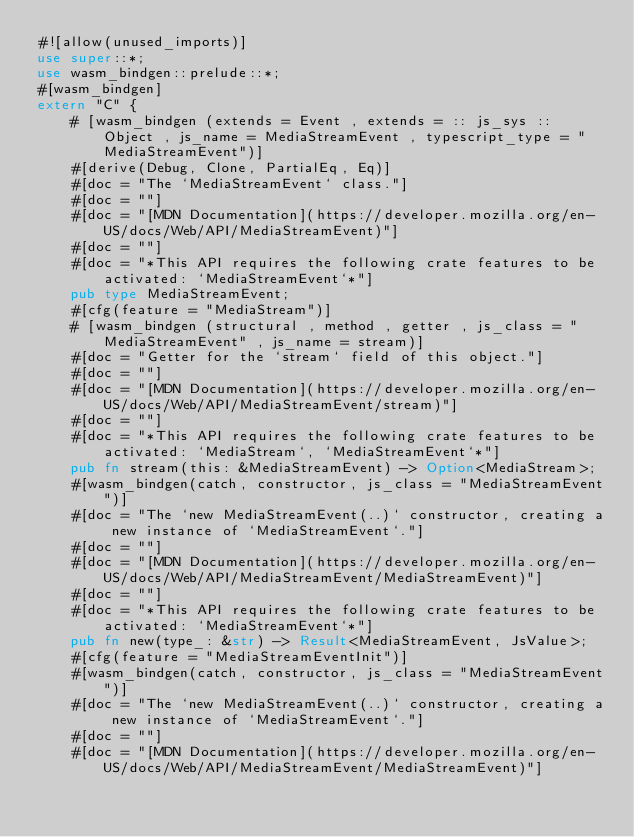<code> <loc_0><loc_0><loc_500><loc_500><_Rust_>#![allow(unused_imports)]
use super::*;
use wasm_bindgen::prelude::*;
#[wasm_bindgen]
extern "C" {
    # [wasm_bindgen (extends = Event , extends = :: js_sys :: Object , js_name = MediaStreamEvent , typescript_type = "MediaStreamEvent")]
    #[derive(Debug, Clone, PartialEq, Eq)]
    #[doc = "The `MediaStreamEvent` class."]
    #[doc = ""]
    #[doc = "[MDN Documentation](https://developer.mozilla.org/en-US/docs/Web/API/MediaStreamEvent)"]
    #[doc = ""]
    #[doc = "*This API requires the following crate features to be activated: `MediaStreamEvent`*"]
    pub type MediaStreamEvent;
    #[cfg(feature = "MediaStream")]
    # [wasm_bindgen (structural , method , getter , js_class = "MediaStreamEvent" , js_name = stream)]
    #[doc = "Getter for the `stream` field of this object."]
    #[doc = ""]
    #[doc = "[MDN Documentation](https://developer.mozilla.org/en-US/docs/Web/API/MediaStreamEvent/stream)"]
    #[doc = ""]
    #[doc = "*This API requires the following crate features to be activated: `MediaStream`, `MediaStreamEvent`*"]
    pub fn stream(this: &MediaStreamEvent) -> Option<MediaStream>;
    #[wasm_bindgen(catch, constructor, js_class = "MediaStreamEvent")]
    #[doc = "The `new MediaStreamEvent(..)` constructor, creating a new instance of `MediaStreamEvent`."]
    #[doc = ""]
    #[doc = "[MDN Documentation](https://developer.mozilla.org/en-US/docs/Web/API/MediaStreamEvent/MediaStreamEvent)"]
    #[doc = ""]
    #[doc = "*This API requires the following crate features to be activated: `MediaStreamEvent`*"]
    pub fn new(type_: &str) -> Result<MediaStreamEvent, JsValue>;
    #[cfg(feature = "MediaStreamEventInit")]
    #[wasm_bindgen(catch, constructor, js_class = "MediaStreamEvent")]
    #[doc = "The `new MediaStreamEvent(..)` constructor, creating a new instance of `MediaStreamEvent`."]
    #[doc = ""]
    #[doc = "[MDN Documentation](https://developer.mozilla.org/en-US/docs/Web/API/MediaStreamEvent/MediaStreamEvent)"]</code> 